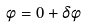<formula> <loc_0><loc_0><loc_500><loc_500>\phi = 0 + \delta \phi</formula> 